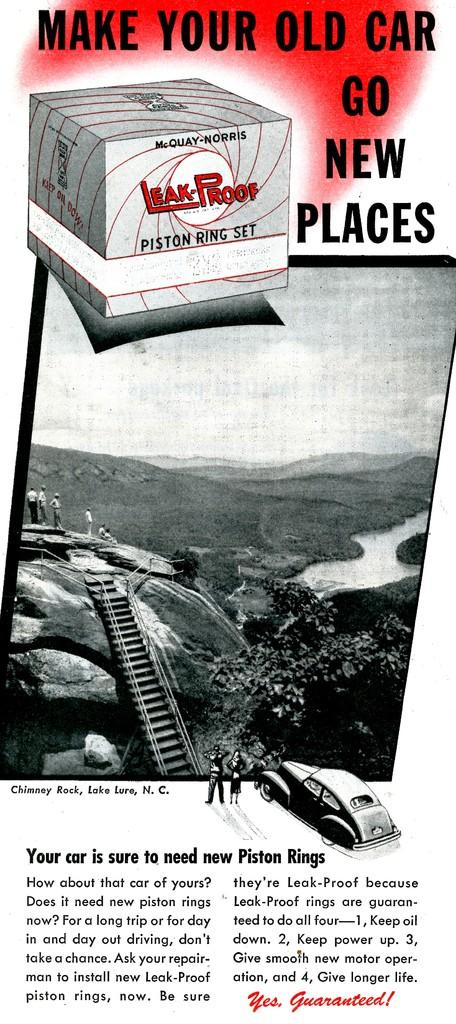Provide a one-sentence caption for the provided image. The advertisement is for leak proof piston ring set. 